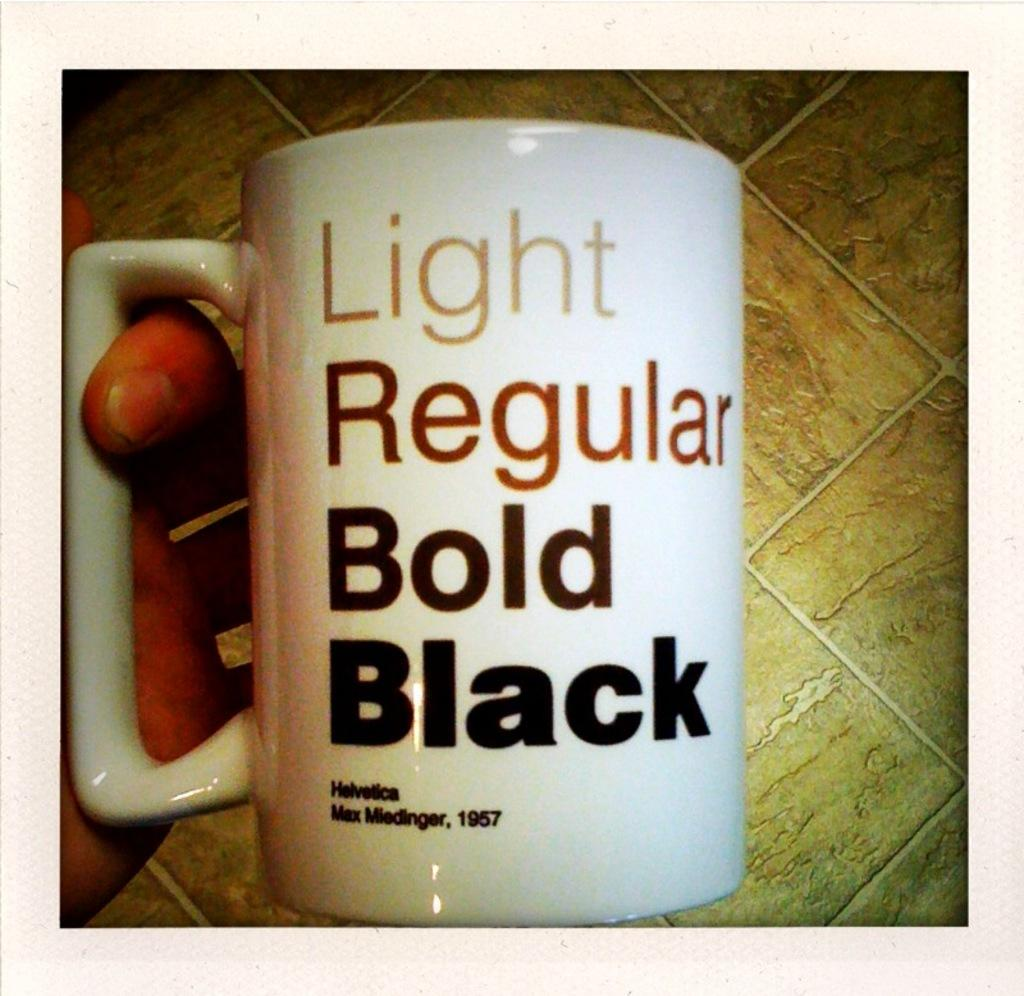Who or what is the main subject in the image? There is a person in the image. What is the person holding in the image? The person is holding a cup. Where is the cup located in relation to the person? The cup is in the person's hand. What can be seen on the cup? There is text on the cup. What is visible in the background of the image? The background of the image includes a floor. What type of summer activity is the person participating in while holding the cup? The image does not depict any summer activities, and the person is simply holding a cup. Is there a bed or bath visible in the image? No, there is no bed or bath present in the image. 